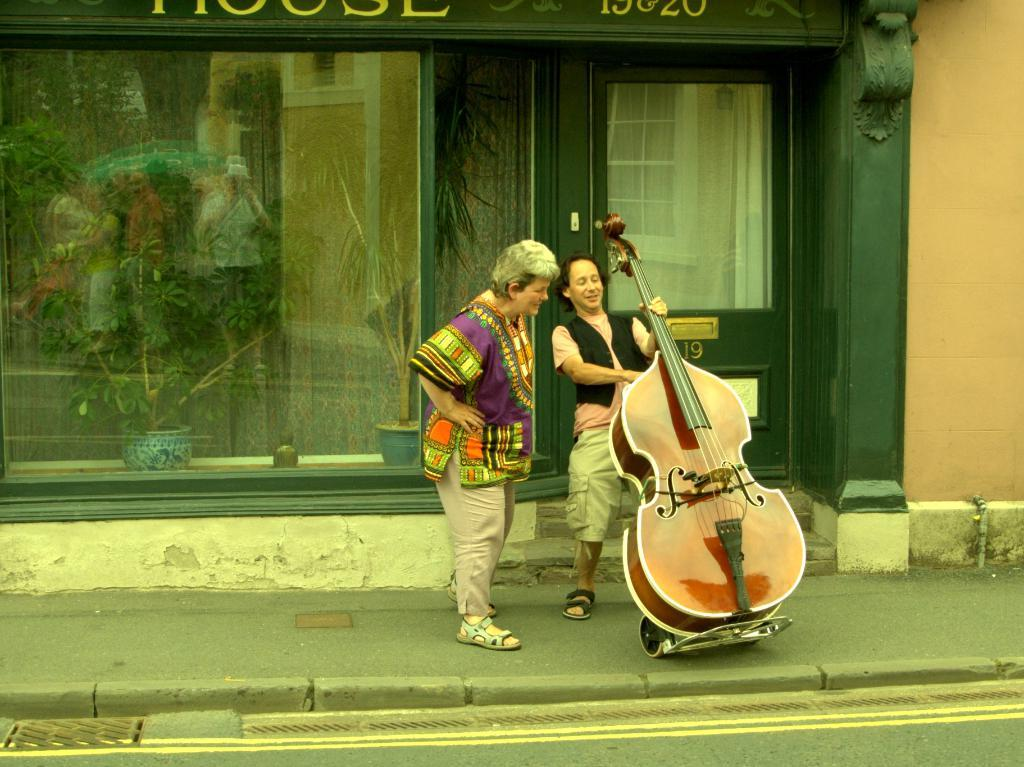What type of establishment can be seen in the background of the image? There is a store in the background of the image. What feature is present in the foreground of the image? There is a door in the image. What are the people near the store doing? There are people standing near the store. What object is being held by one of the individuals? One person is holding a guitar in their hand. What can be seen in the distance in the image? There is a road visible in the image. What appliance is being used to fix the error in the image? There is no appliance or error present in the image; it is a scene featuring a store, door, people, and a road. 